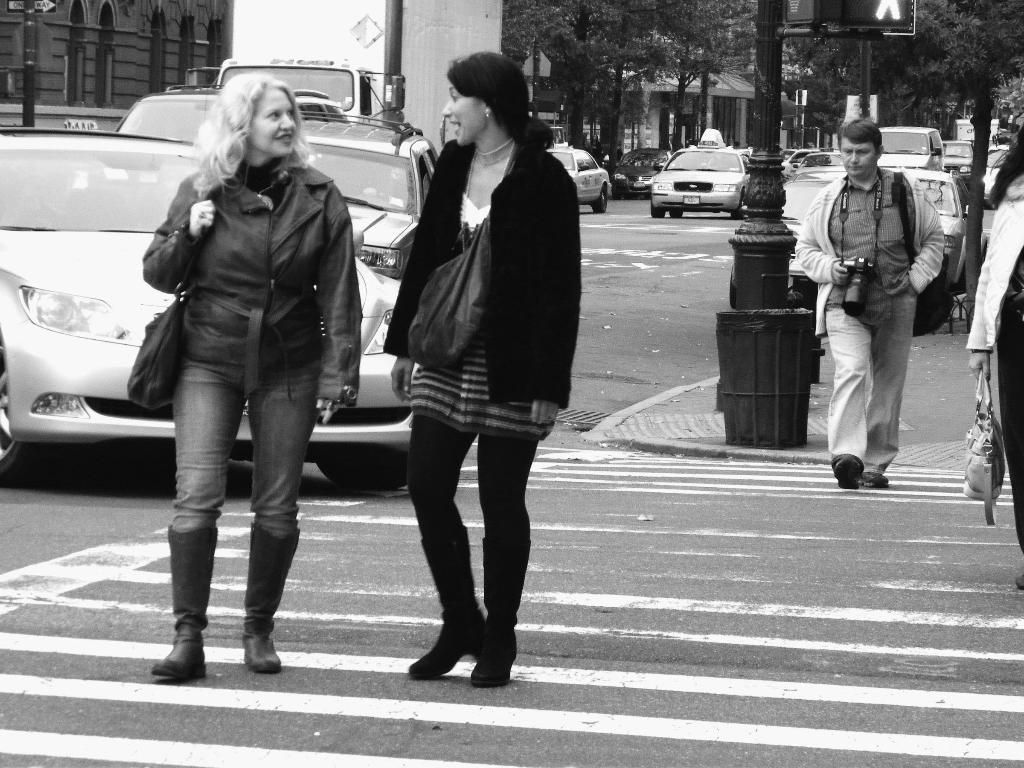How would you summarize this image in a sentence or two? It is a black and white picture of vehicles on the road. Image also consists of trees, poles and buildings. There are four persons walking on the road. 